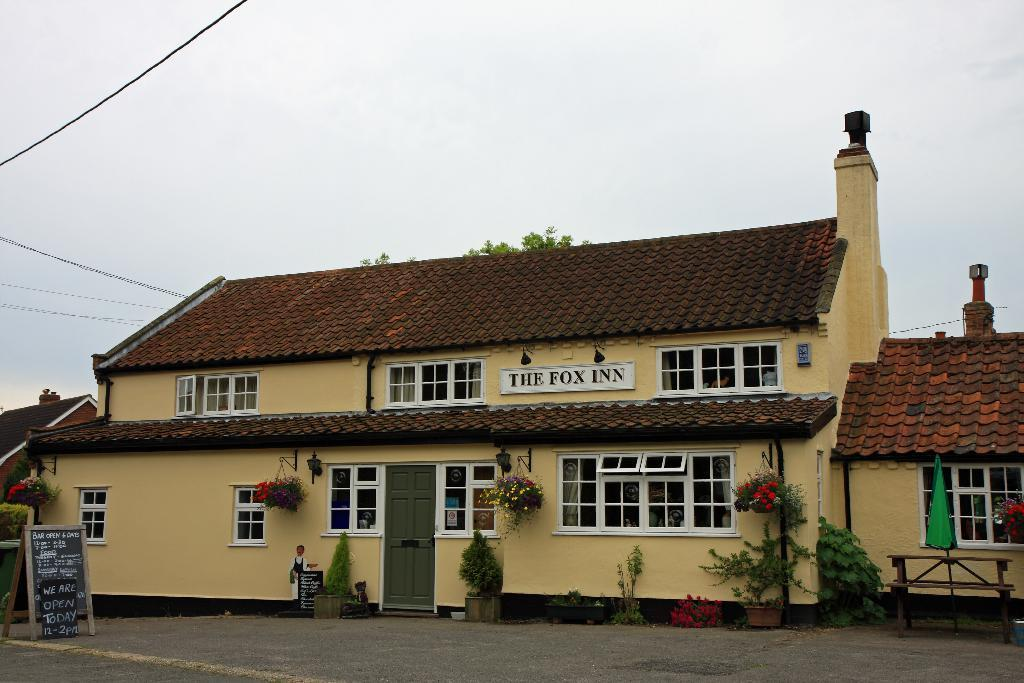How many houses can be seen in the image? There are two houses in the image. What else is present in the image besides the houses? There are many plants and a tree in the image. Can you describe the board in the image? There is a board in the image, but its specific purpose or appearance is not mentioned in the facts. What is visible in the background of the image? The sky is visible in the image. What type of riddle is written on the board in the image? There is no mention of a riddle or any writing on the board in the image. Is there a prison visible in the image? There is no mention of a prison in the image; it only contains two houses, plants, a tree, a board, and the sky. 